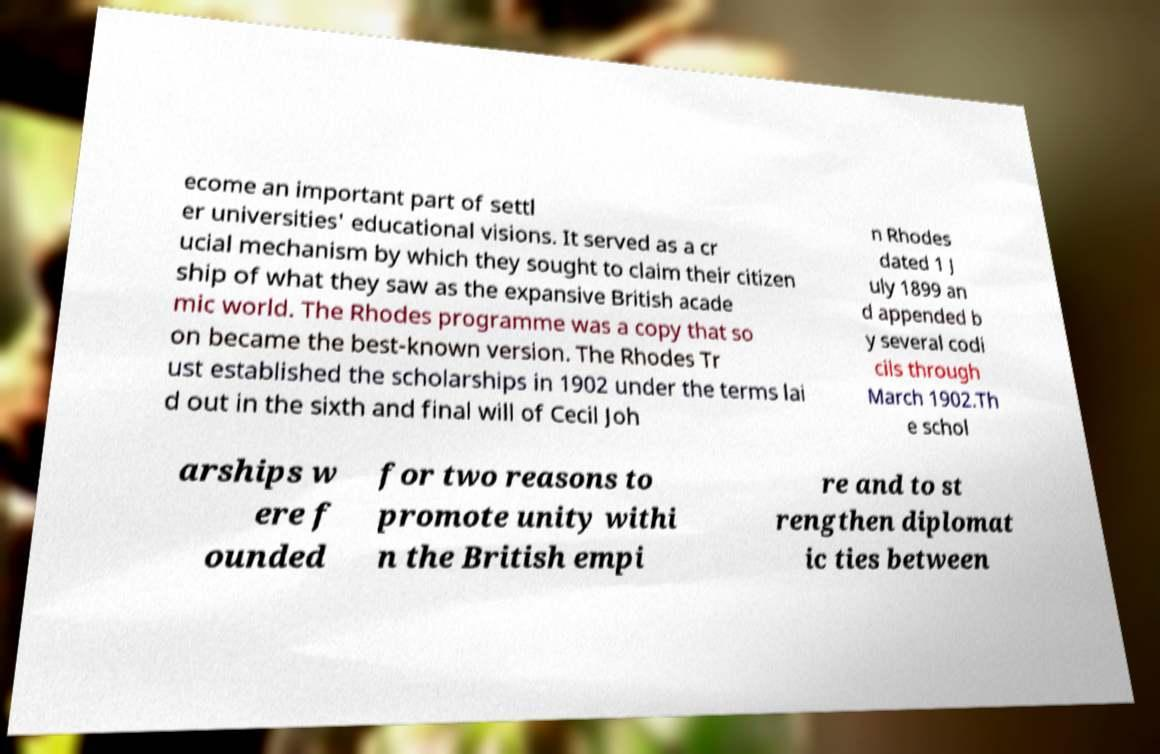Could you extract and type out the text from this image? ecome an important part of settl er universities' educational visions. It served as a cr ucial mechanism by which they sought to claim their citizen ship of what they saw as the expansive British acade mic world. The Rhodes programme was a copy that so on became the best-known version. The Rhodes Tr ust established the scholarships in 1902 under the terms lai d out in the sixth and final will of Cecil Joh n Rhodes dated 1 J uly 1899 an d appended b y several codi cils through March 1902.Th e schol arships w ere f ounded for two reasons to promote unity withi n the British empi re and to st rengthen diplomat ic ties between 